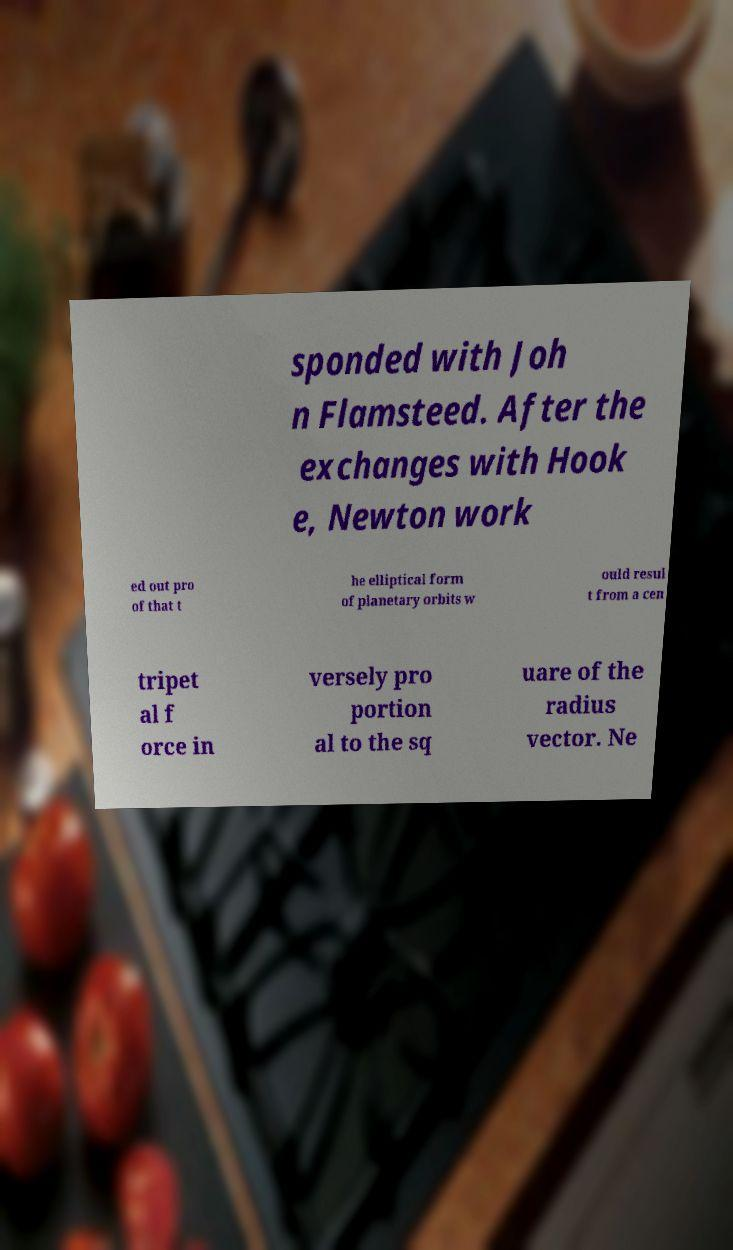Could you extract and type out the text from this image? sponded with Joh n Flamsteed. After the exchanges with Hook e, Newton work ed out pro of that t he elliptical form of planetary orbits w ould resul t from a cen tripet al f orce in versely pro portion al to the sq uare of the radius vector. Ne 